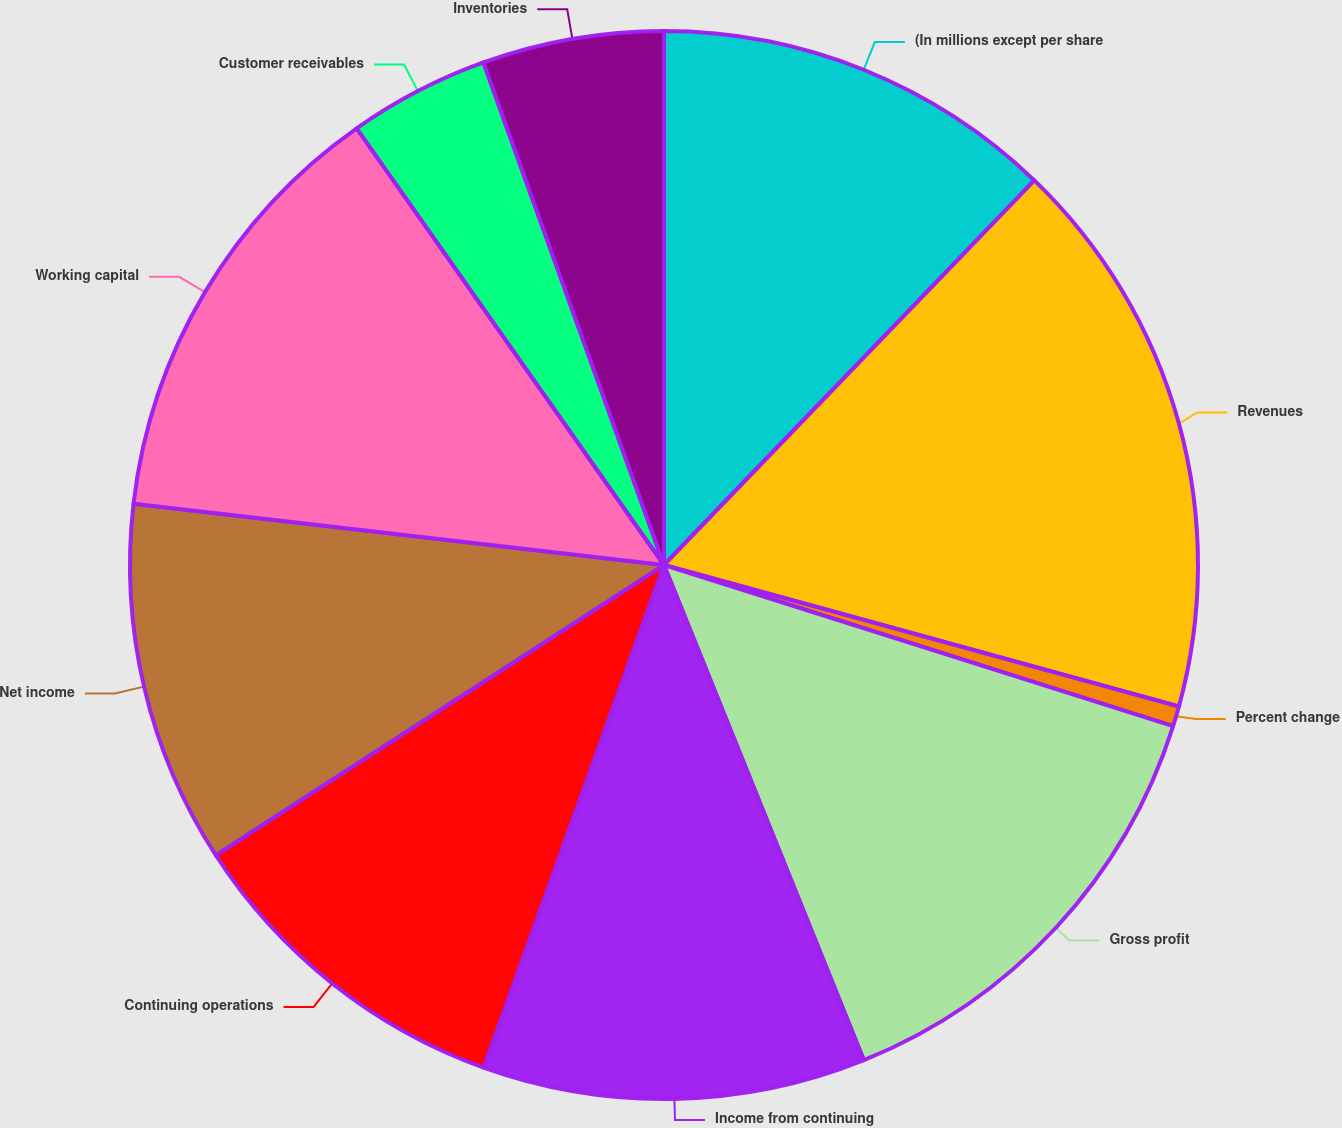Convert chart to OTSL. <chart><loc_0><loc_0><loc_500><loc_500><pie_chart><fcel>(In millions except per share<fcel>Revenues<fcel>Percent change<fcel>Gross profit<fcel>Income from continuing<fcel>Continuing operations<fcel>Net income<fcel>Working capital<fcel>Customer receivables<fcel>Inventories<nl><fcel>12.2%<fcel>17.07%<fcel>0.61%<fcel>14.02%<fcel>11.59%<fcel>10.37%<fcel>10.98%<fcel>13.41%<fcel>4.27%<fcel>5.49%<nl></chart> 